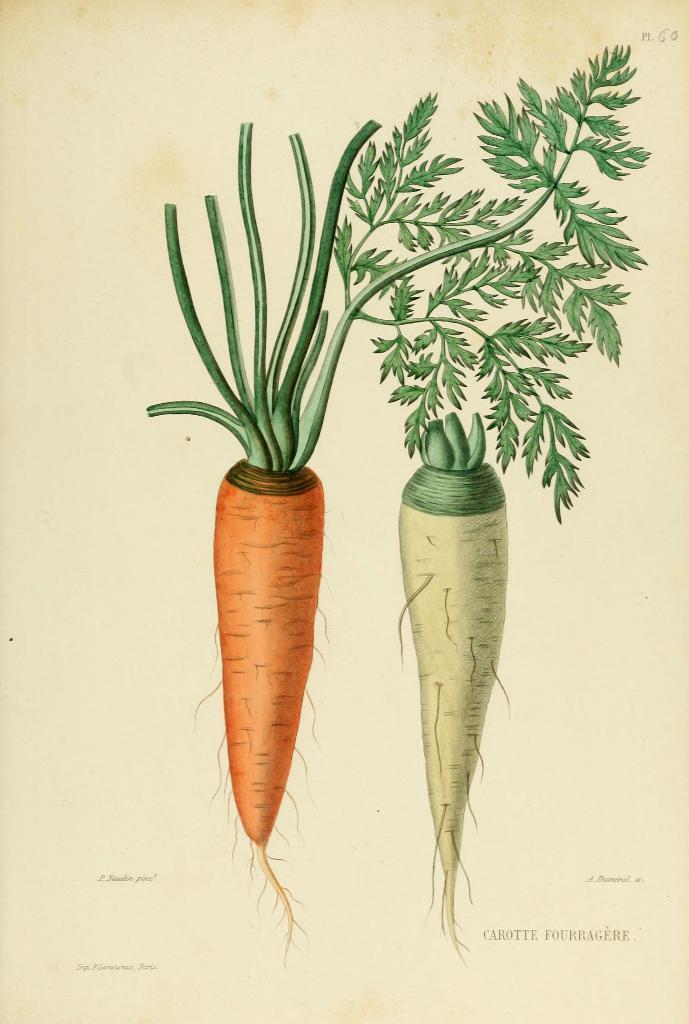Can you describe this image briefly? In the image there is an art of a radish beside a carrot. 